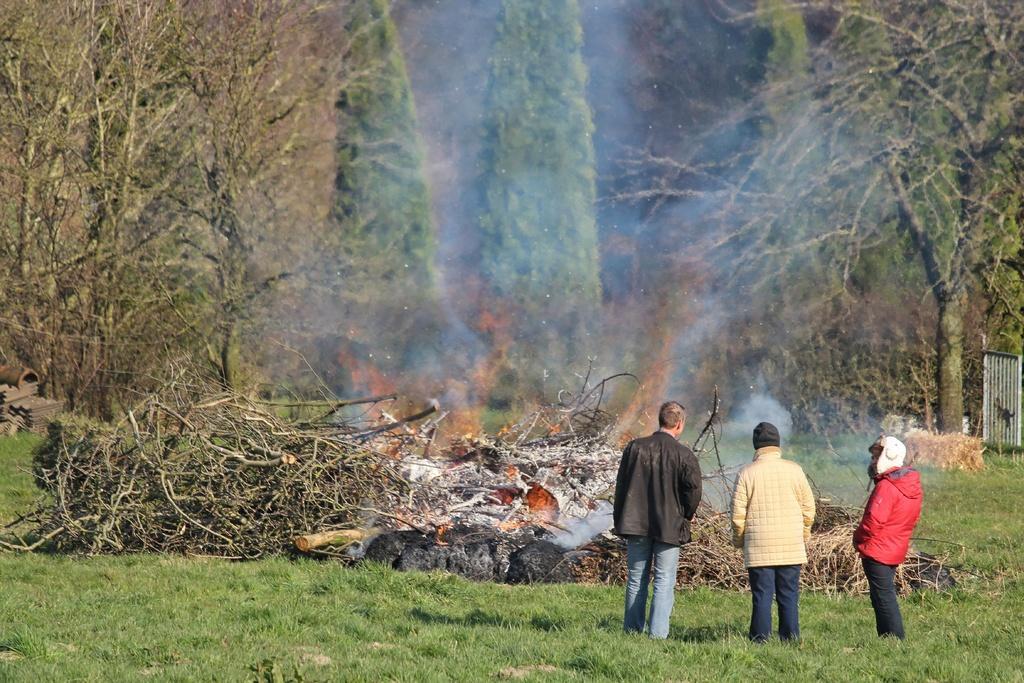Can you describe this image briefly? In this image there are people standing on the grassland. There are wooden trunks having a fire. Background there are trees. Right side there is a fence. 